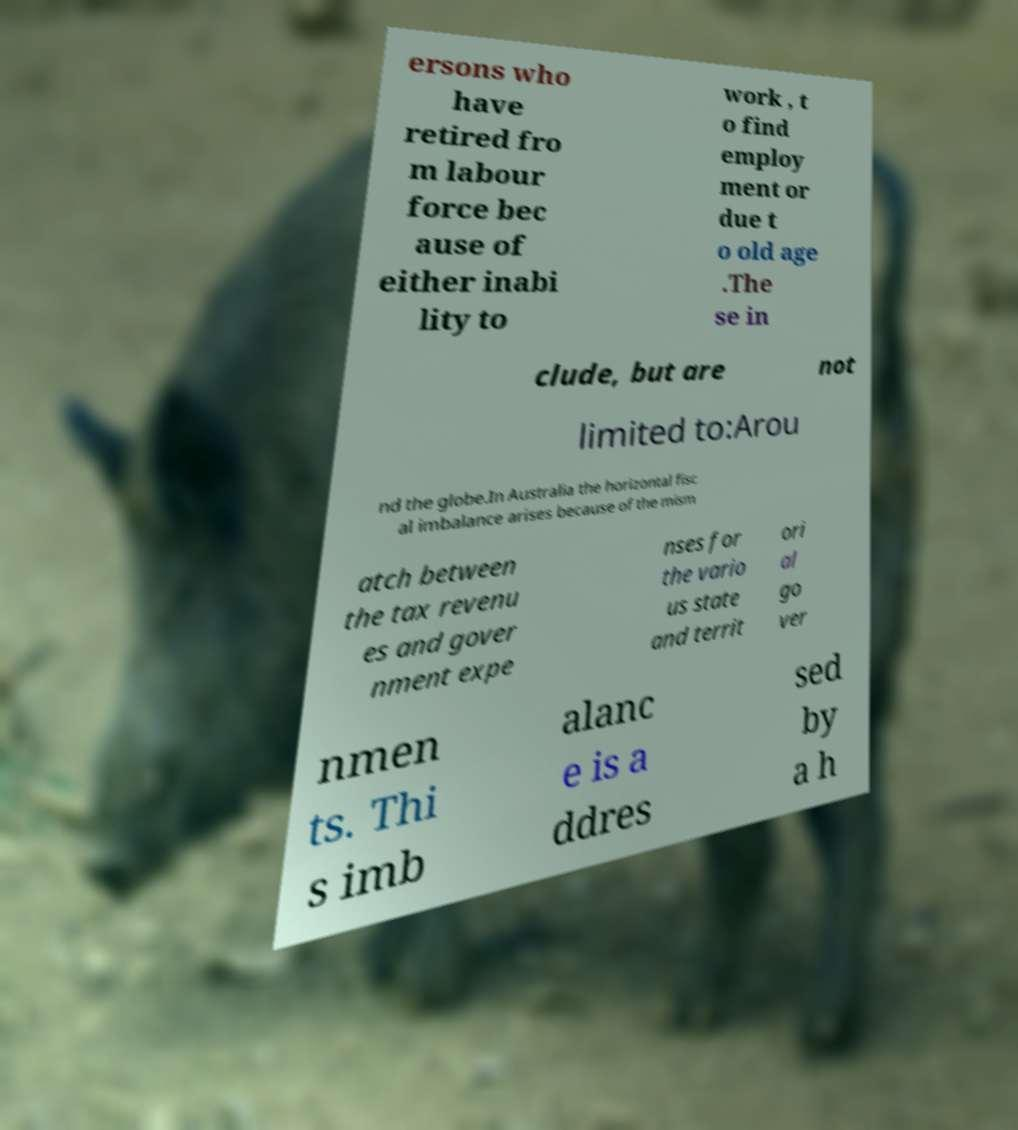I need the written content from this picture converted into text. Can you do that? ersons who have retired fro m labour force bec ause of either inabi lity to work , t o find employ ment or due t o old age .The se in clude, but are not limited to:Arou nd the globe.In Australia the horizontal fisc al imbalance arises because of the mism atch between the tax revenu es and gover nment expe nses for the vario us state and territ ori al go ver nmen ts. Thi s imb alanc e is a ddres sed by a h 